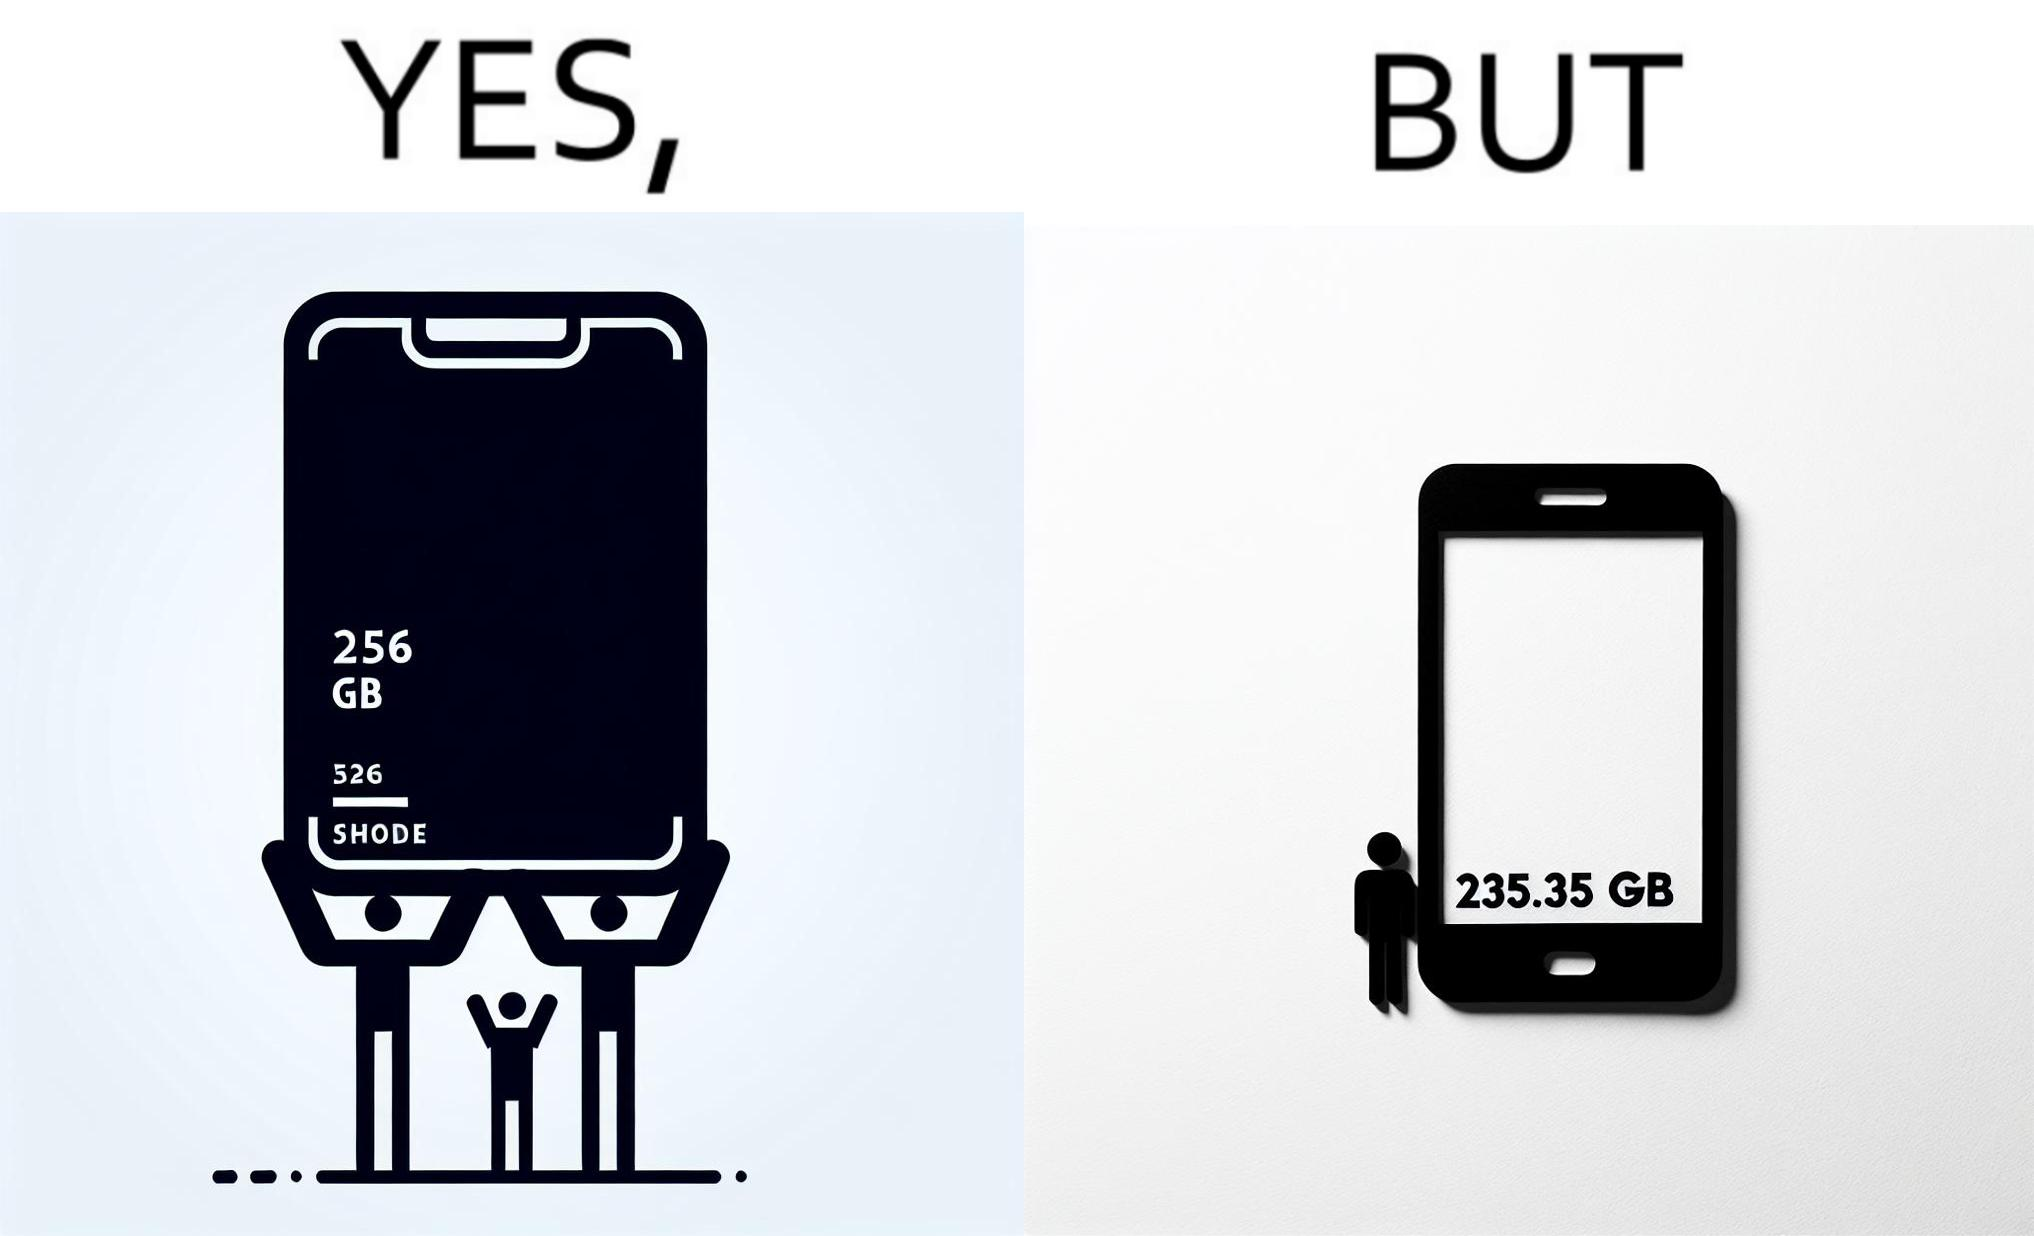Explain why this image is satirical. The images are funny since they show how smartphone manufacturers advertise their smartphones to have a high internal storage space but in reality, the amount of space available to an user is considerably less due to pre-installed software 